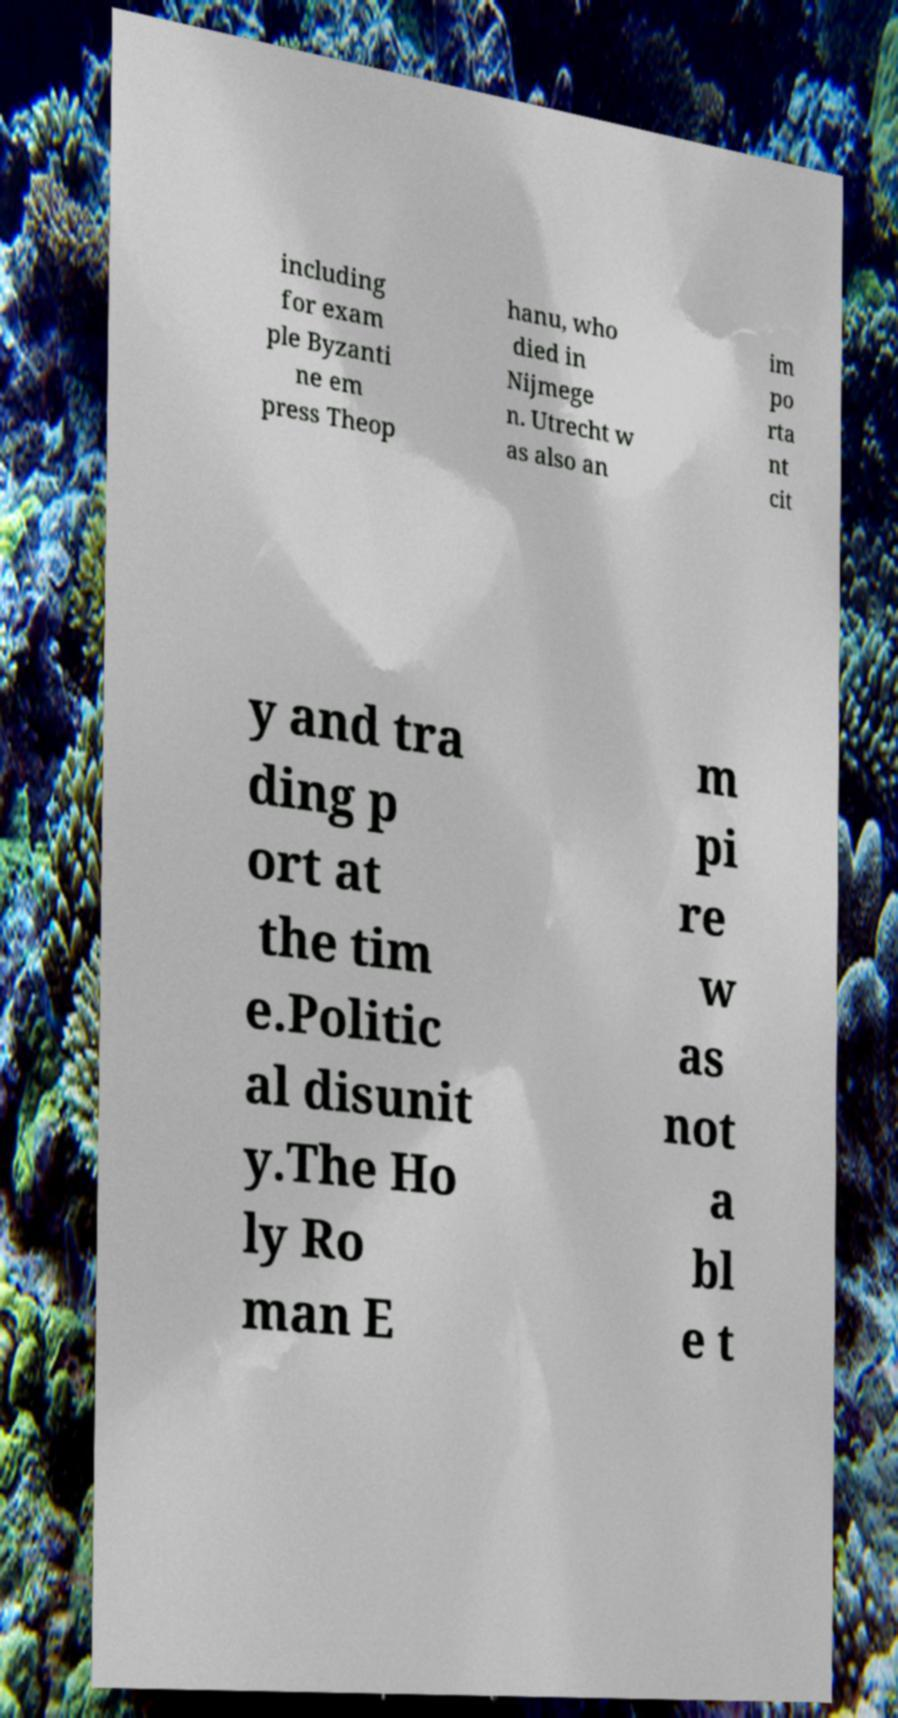Please read and relay the text visible in this image. What does it say? including for exam ple Byzanti ne em press Theop hanu, who died in Nijmege n. Utrecht w as also an im po rta nt cit y and tra ding p ort at the tim e.Politic al disunit y.The Ho ly Ro man E m pi re w as not a bl e t 